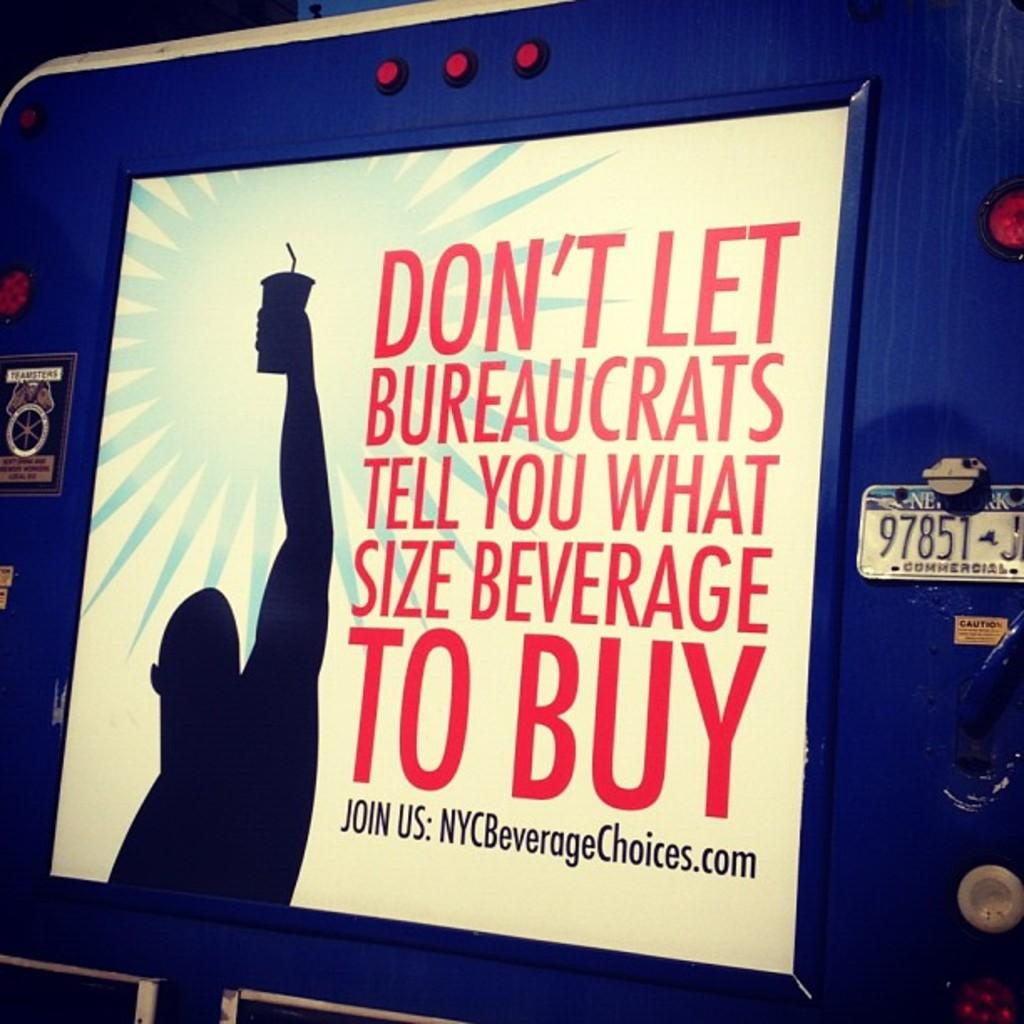Provide a one-sentence caption for the provided image. A protest sign against New York drink sizes with a website link titled NYCBeverageChoices on it. 